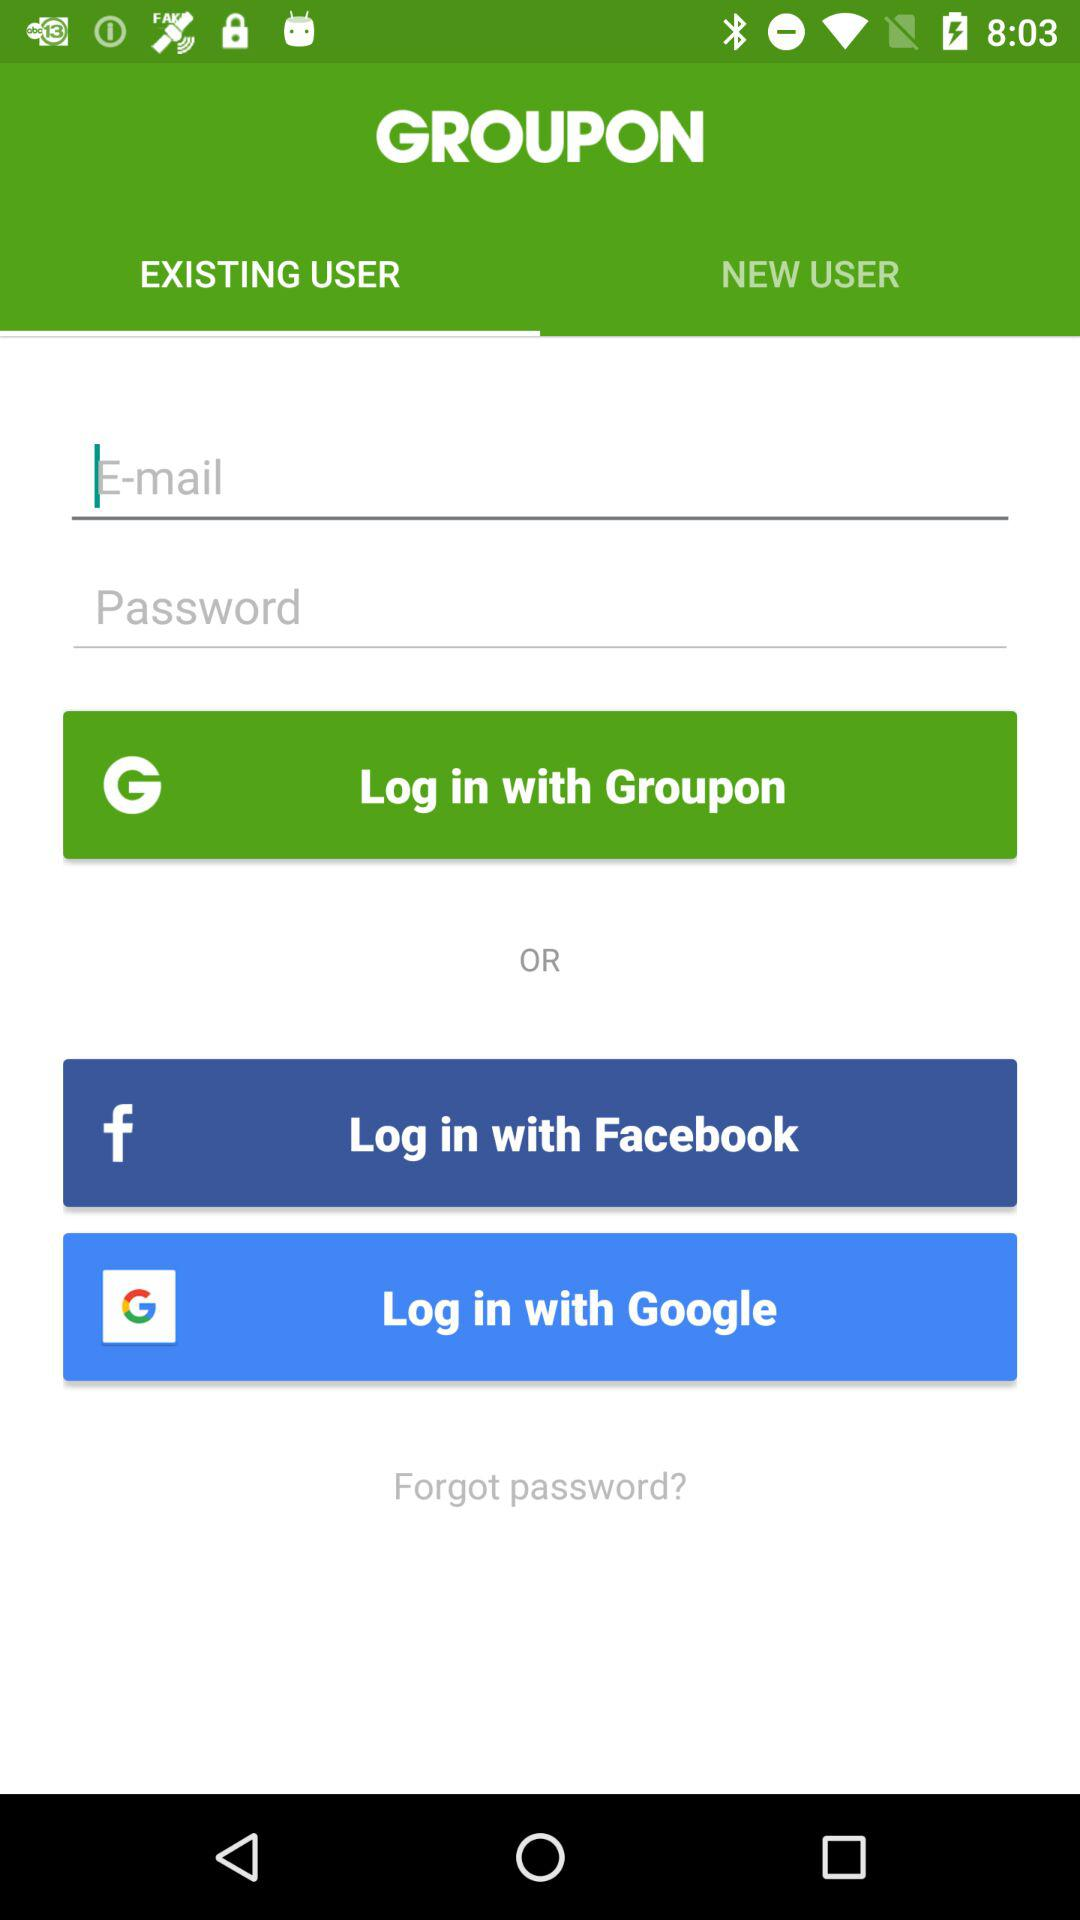What is the app title? The app title is "GROUPON". 